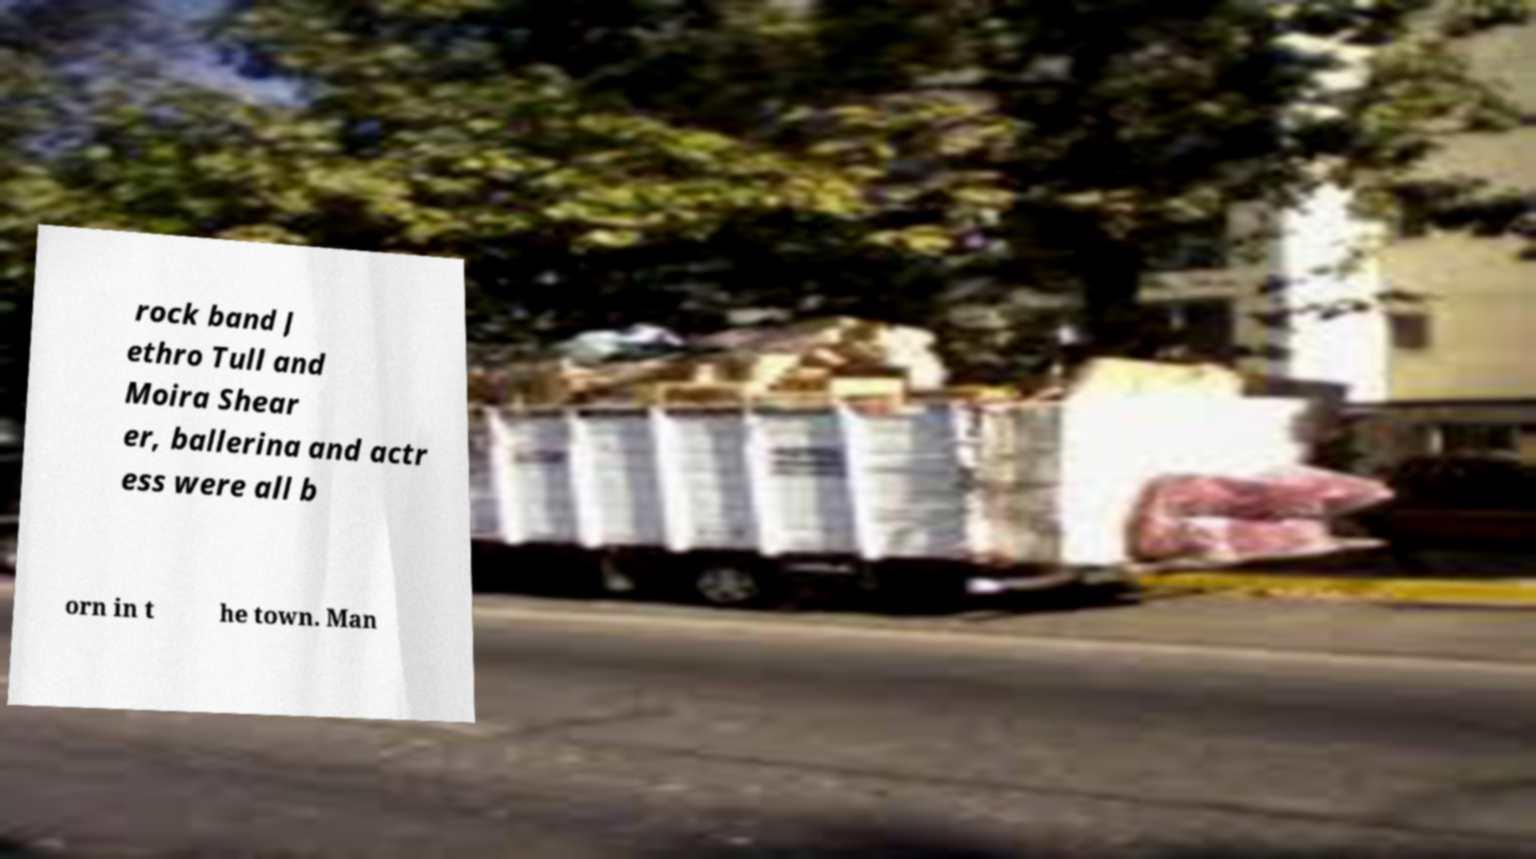Can you read and provide the text displayed in the image?This photo seems to have some interesting text. Can you extract and type it out for me? rock band J ethro Tull and Moira Shear er, ballerina and actr ess were all b orn in t he town. Man 